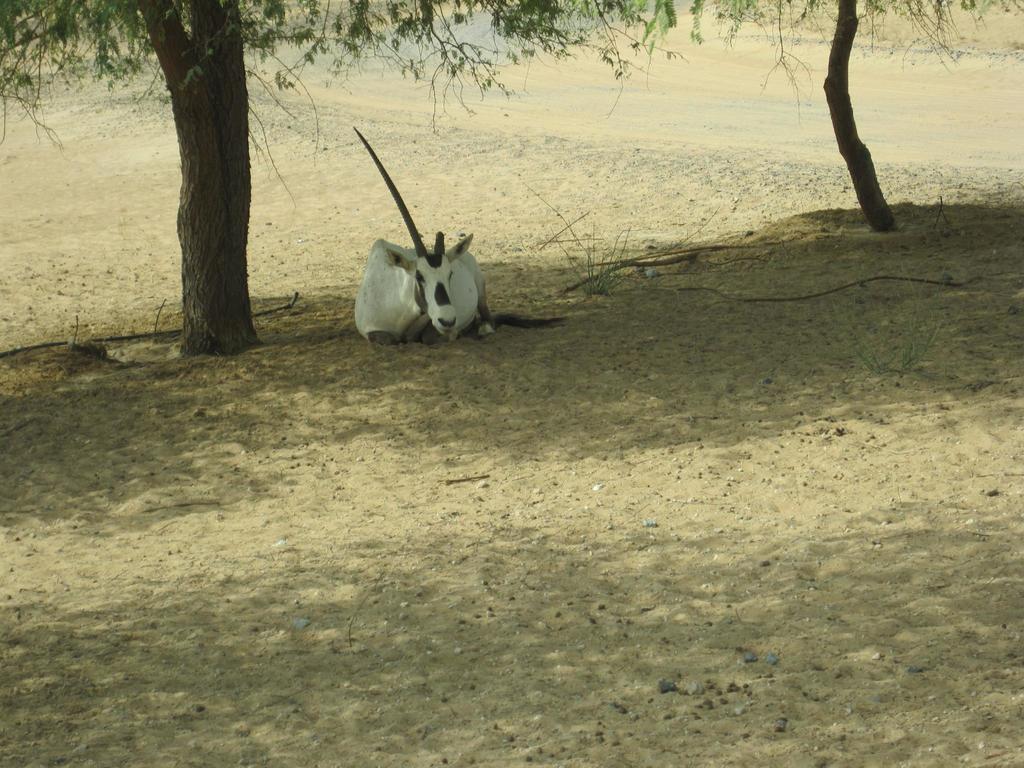Describe this image in one or two sentences. In the image we can see an animal black and white in color. This is a sand, tree trunk and leaves. 